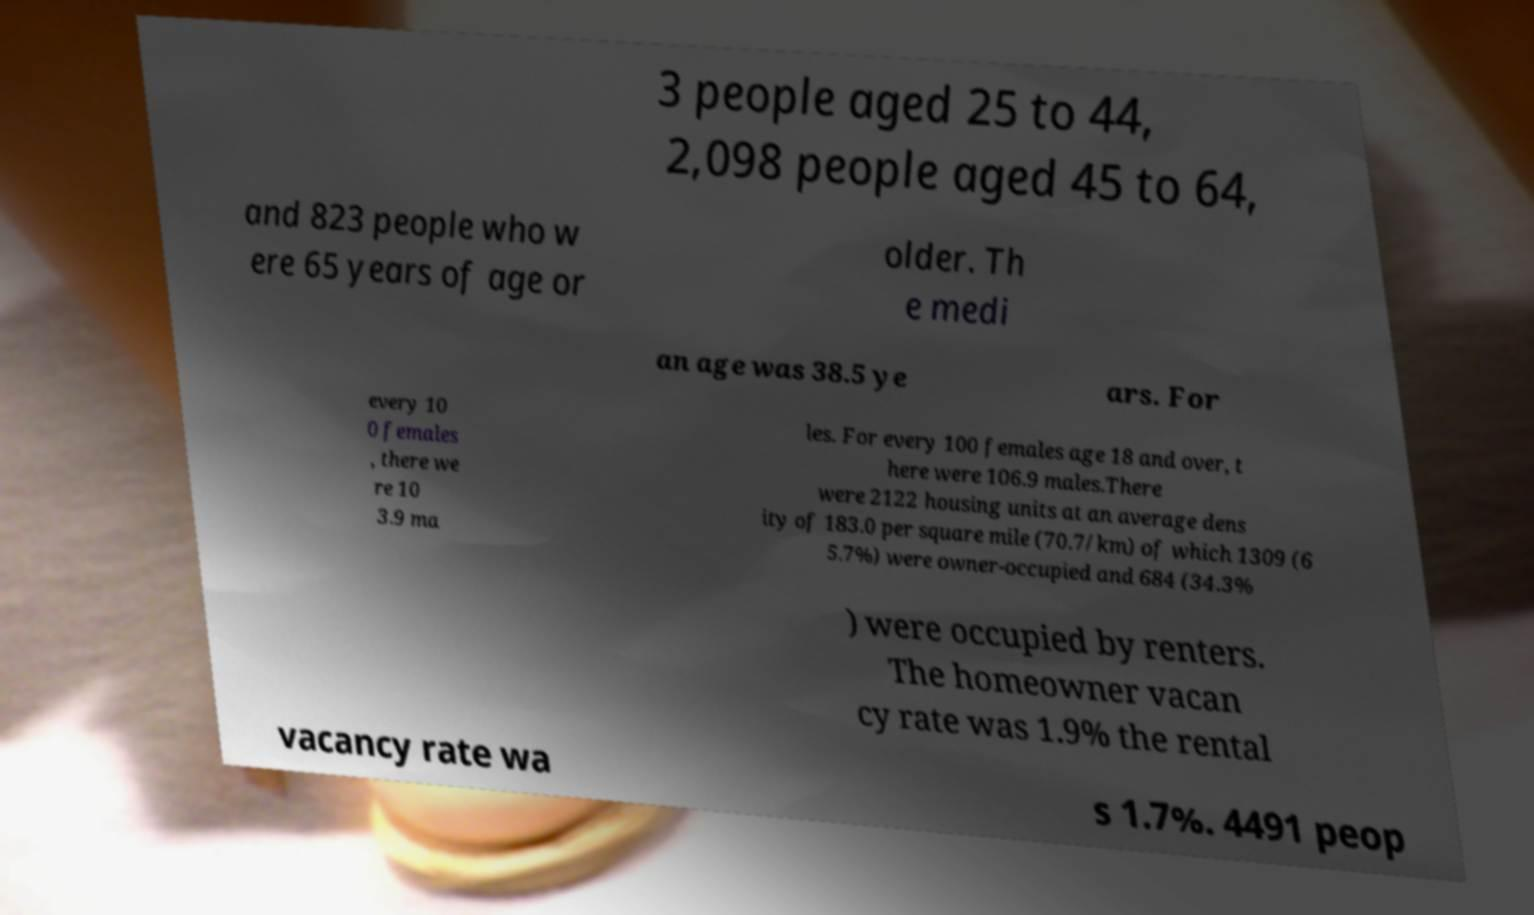For documentation purposes, I need the text within this image transcribed. Could you provide that? 3 people aged 25 to 44, 2,098 people aged 45 to 64, and 823 people who w ere 65 years of age or older. Th e medi an age was 38.5 ye ars. For every 10 0 females , there we re 10 3.9 ma les. For every 100 females age 18 and over, t here were 106.9 males.There were 2122 housing units at an average dens ity of 183.0 per square mile (70.7/km) of which 1309 (6 5.7%) were owner-occupied and 684 (34.3% ) were occupied by renters. The homeowner vacan cy rate was 1.9% the rental vacancy rate wa s 1.7%. 4491 peop 